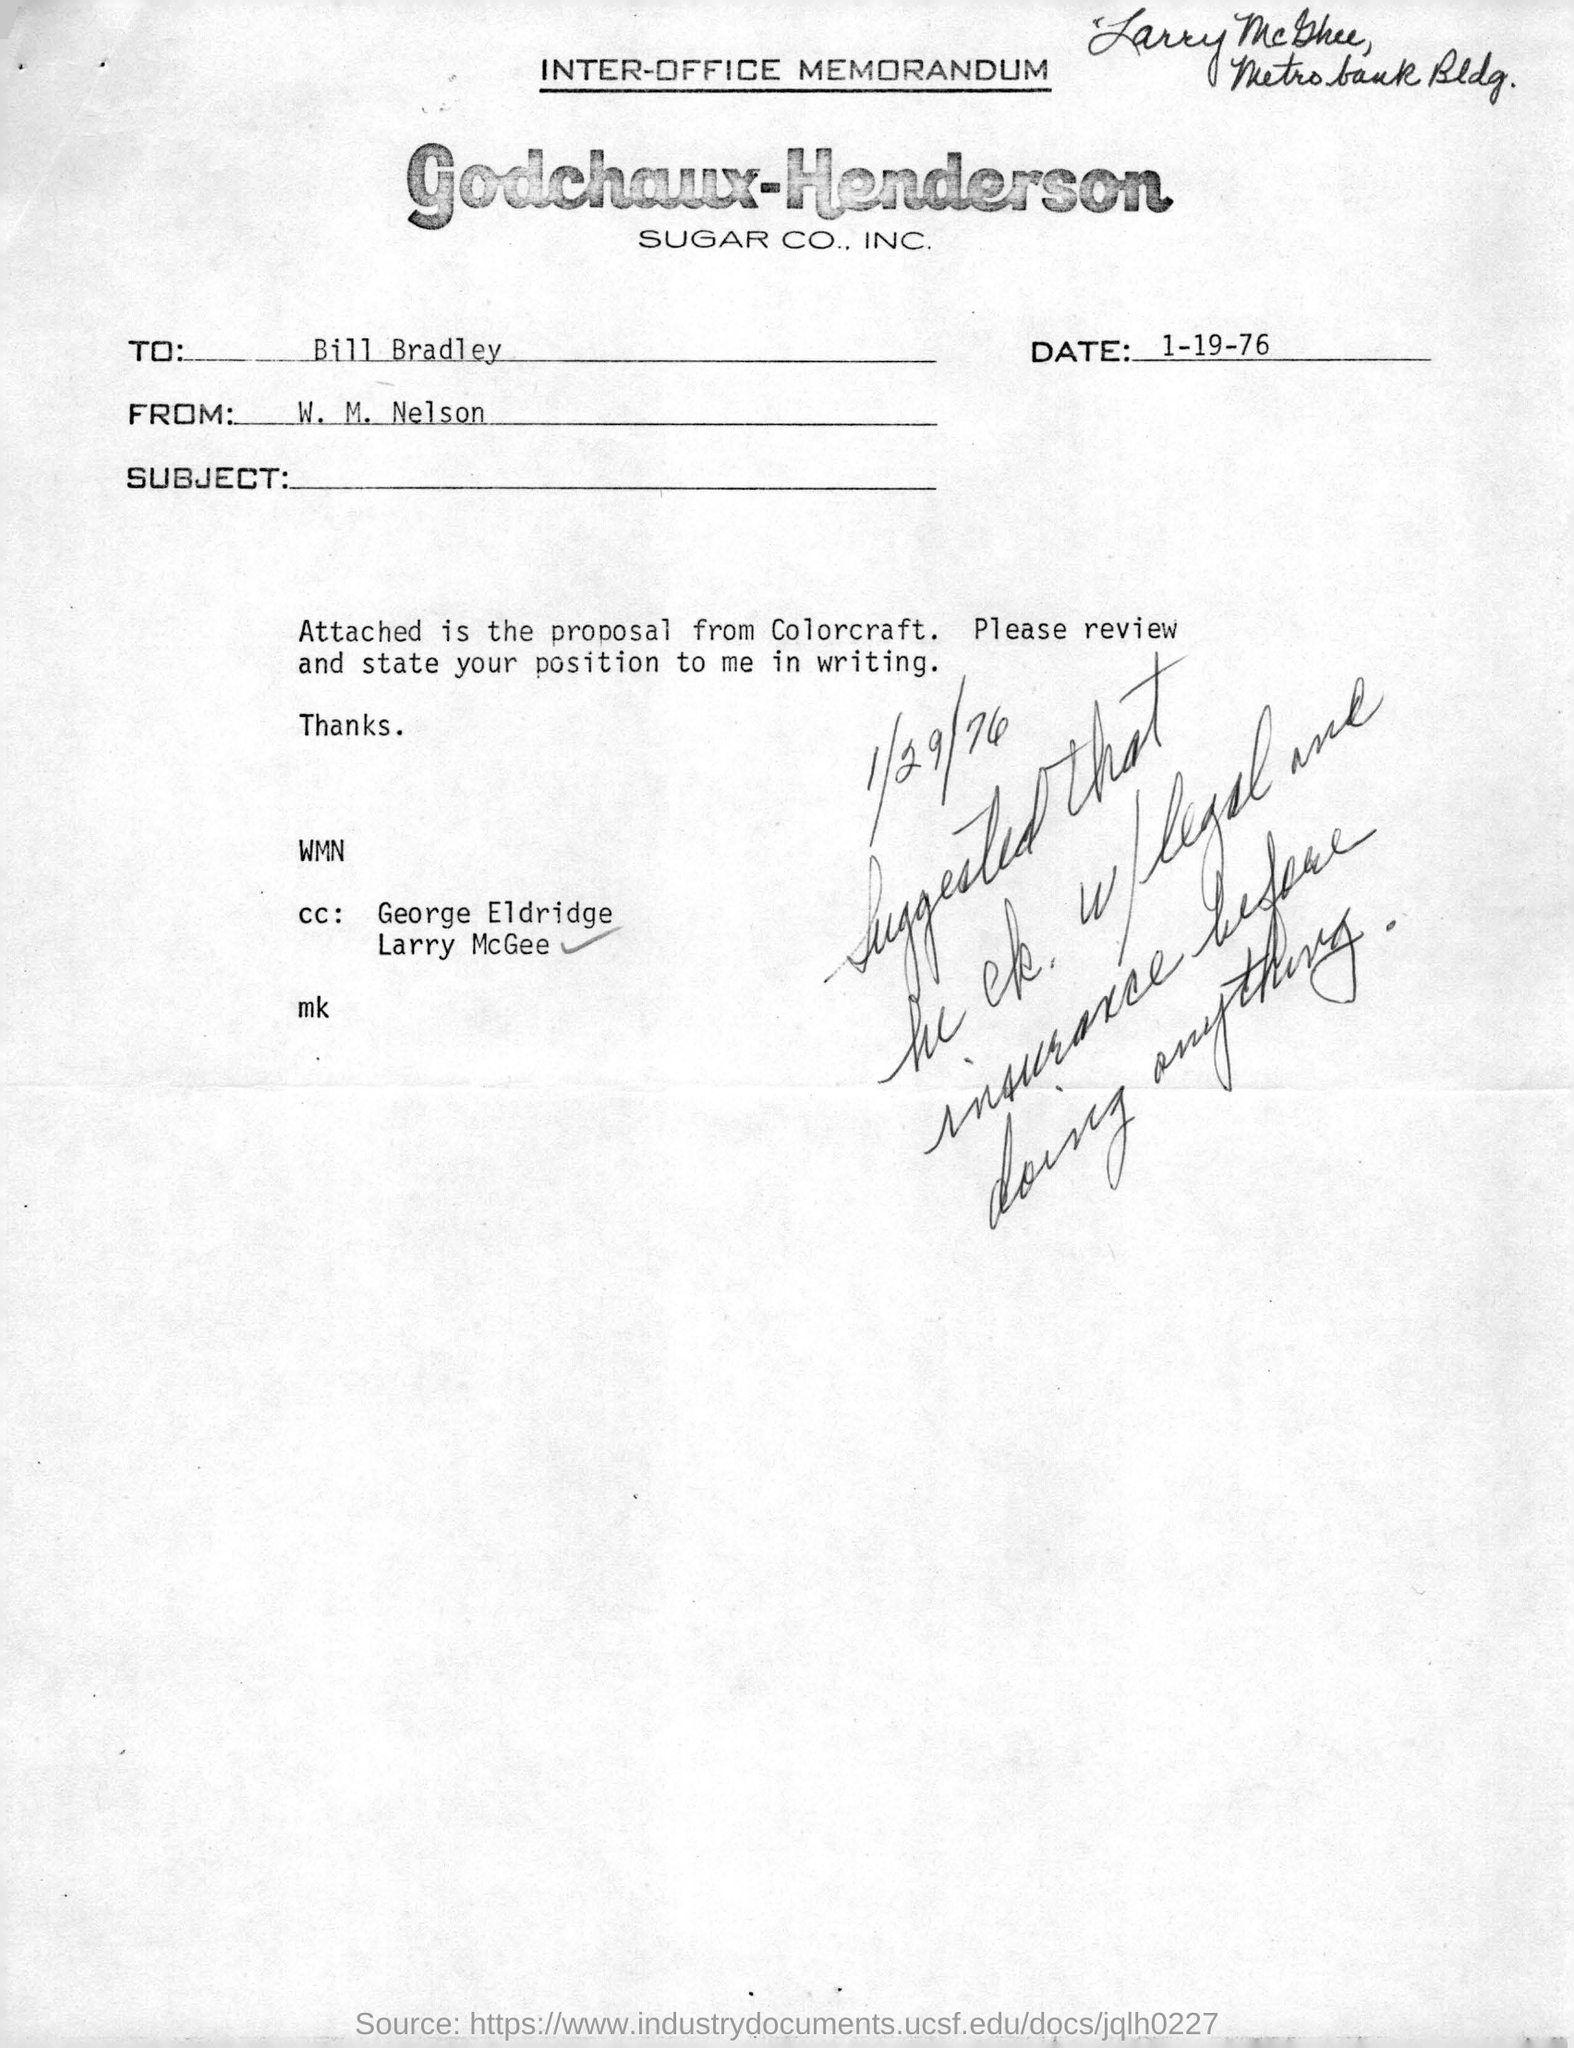What kind of communication is this?
Your response must be concise. INTER-OFFICE MEMORANDUM. Which company's memorandum is given here?
Your response must be concise. Godchaux-Henderson SUGAR CO., INC. Who is the sender of this memorandum?
Keep it short and to the point. W. M. Nelson. To whom, the memorandum is addressed?
Make the answer very short. BILL BRADLEY. What is the date mentioned in the memorandum?
Give a very brief answer. 1-19-76. 